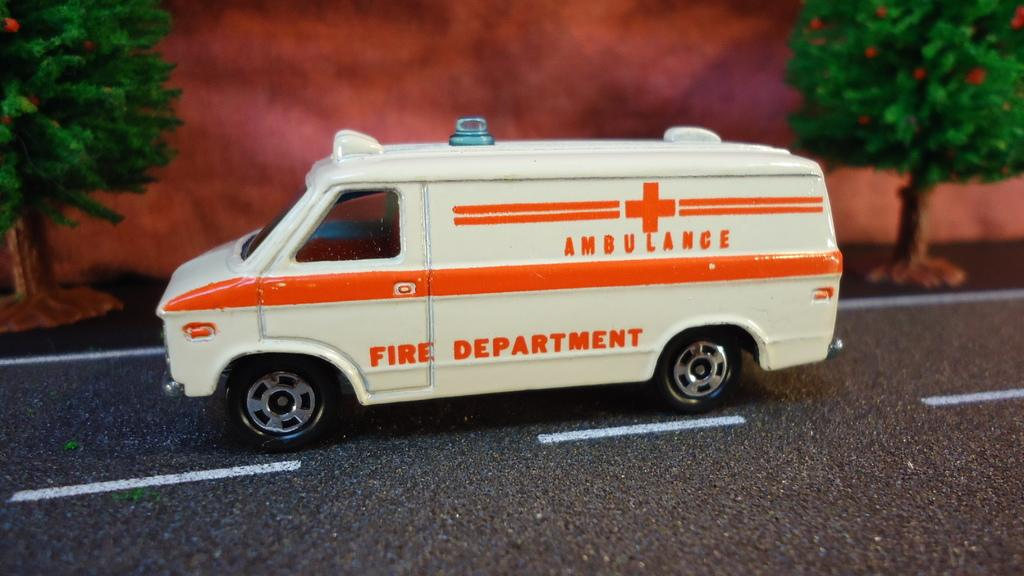What is on the road in the image? There is a toy vehicle on the road. What can be seen in the background of the image? There are toy trees in the background. What statement can be seen written on the toy vehicle in the image? There is no statement visible on the toy vehicle in the image. What type of cracker is present on the toy vehicle in the image? There is no cracker present on the toy vehicle in the image. 